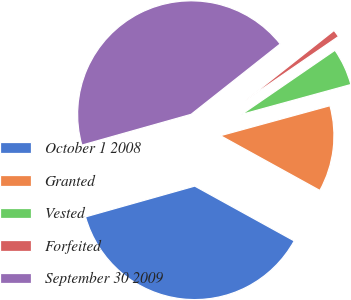Convert chart. <chart><loc_0><loc_0><loc_500><loc_500><pie_chart><fcel>October 1 2008<fcel>Granted<fcel>Vested<fcel>Forfeited<fcel>September 30 2009<nl><fcel>37.61%<fcel>12.27%<fcel>5.33%<fcel>1.06%<fcel>43.73%<nl></chart> 